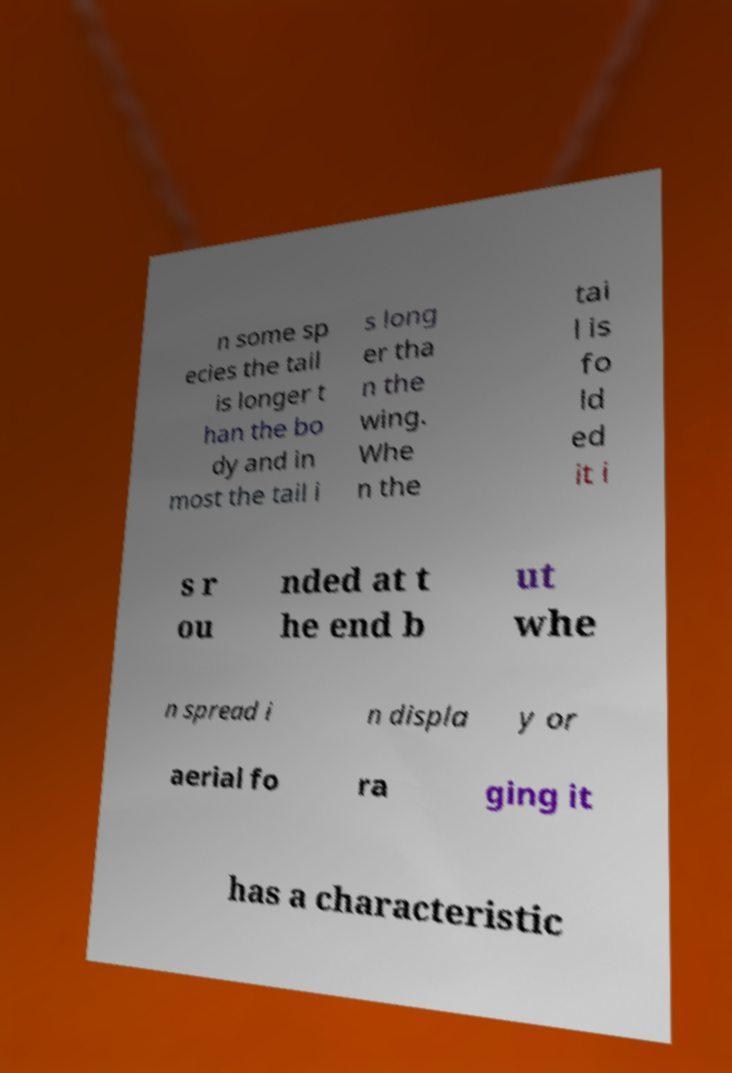Please identify and transcribe the text found in this image. n some sp ecies the tail is longer t han the bo dy and in most the tail i s long er tha n the wing. Whe n the tai l is fo ld ed it i s r ou nded at t he end b ut whe n spread i n displa y or aerial fo ra ging it has a characteristic 